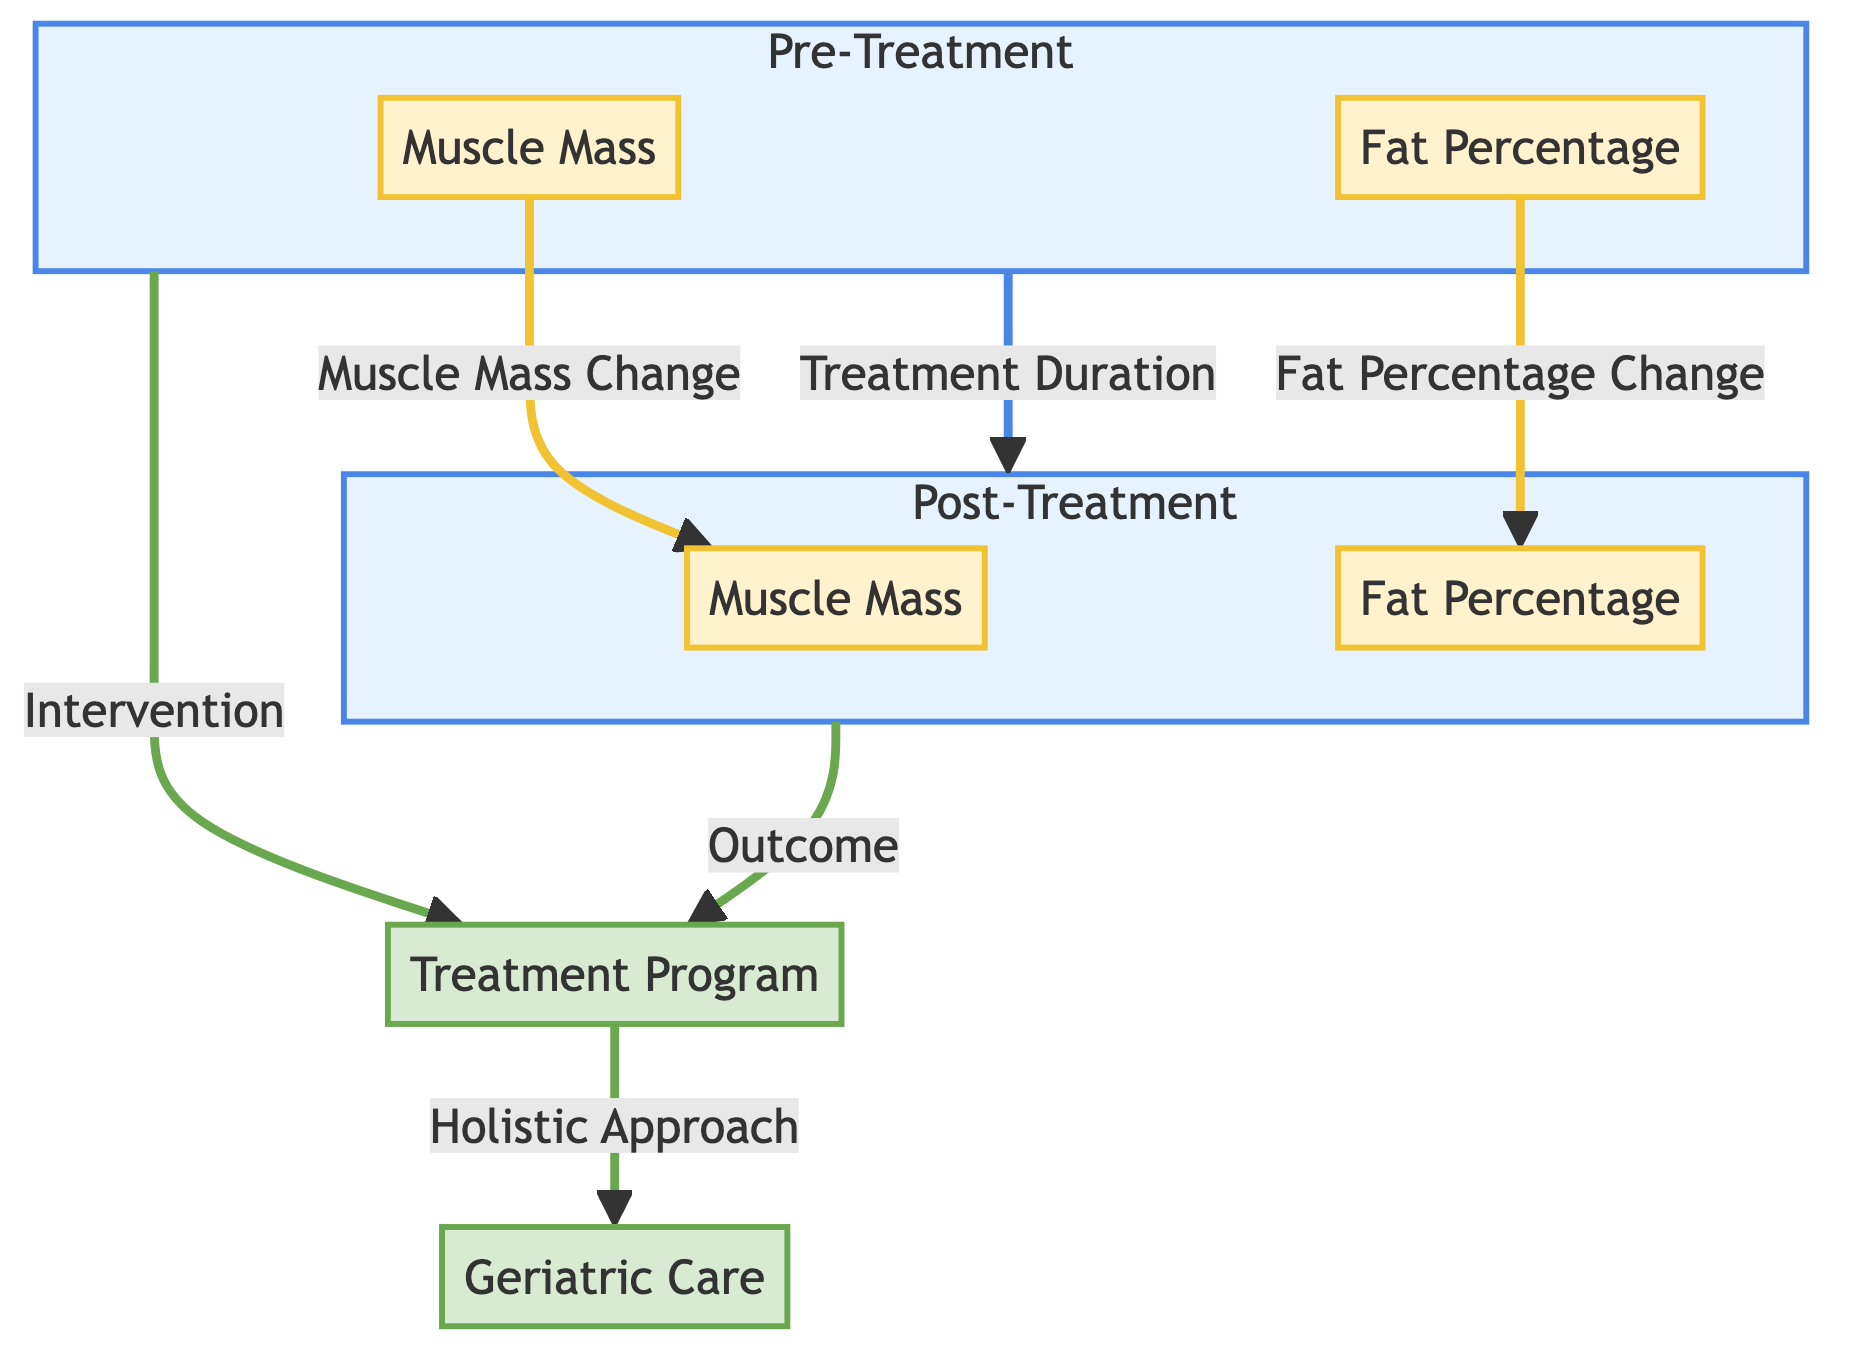What does the "Post-Treatment" subgraph represent? The "Post-Treatment" subgraph represents the changes in muscle mass and fat percentage after treatment. It is indicated as a separate subgraph labeled POST, detailing the outcomes of the treatment program.
Answer: Changes in muscle mass and fat percentage after treatment How many nodes are present in the "Pre-Treatment" section? The "Pre-Treatment" section contains two nodes: one for Muscle Mass and one for Fat Percentage. Counting these nodes gives a total of two.
Answer: Two What is the relationship between "FP" and "FPost"? The relationship between "FP" (Fat Percentage before treatment) and "FPost" (Fat Percentage after treatment) is that "FP" leads to a change which results in "FPost". There is a directed arrow indicating this relationship.
Answer: Fat Percentage Change Which node represents the treatment program? The node representing the treatment program is labeled "Treatment Program." This node is central to both the pre and post-treatment processes in the diagram.
Answer: Treatment Program What color represents the measurement nodes? The measurement nodes are represented in white with a cream outline, indicating their importance in the diagram as specific metrics of body composition changes.
Answer: White What does the arrow from "PRE" to "POST" signify? The arrow from "PRE" to "POST" signifies the effect of the Treatment Duration on the outcomes observed in the Post-Treatment phase. It indicates that changes are expected after the treatment period.
Answer: Treatment Duration What is the primary focus of the overall diagram? The primary focus of the overall diagram is illustrating body composition changes in elderly patients resulting from a structured treatment program involving a holistic approach.
Answer: Body composition changes What kind of approach does the "Treatment Program" lead to? The "Treatment Program" leads to a "Holistic Approach" in geriatric care, which encompasses overall well-being including physical, mental, and social aspects of health for older adults.
Answer: Holistic Approach 